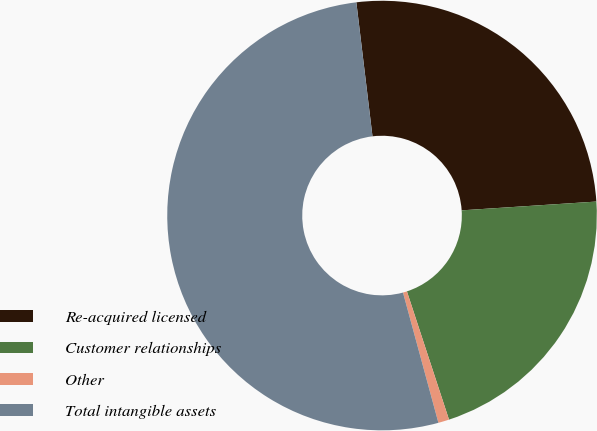Convert chart to OTSL. <chart><loc_0><loc_0><loc_500><loc_500><pie_chart><fcel>Re-acquired licensed<fcel>Customer relationships<fcel>Other<fcel>Total intangible assets<nl><fcel>25.87%<fcel>20.99%<fcel>0.82%<fcel>52.32%<nl></chart> 